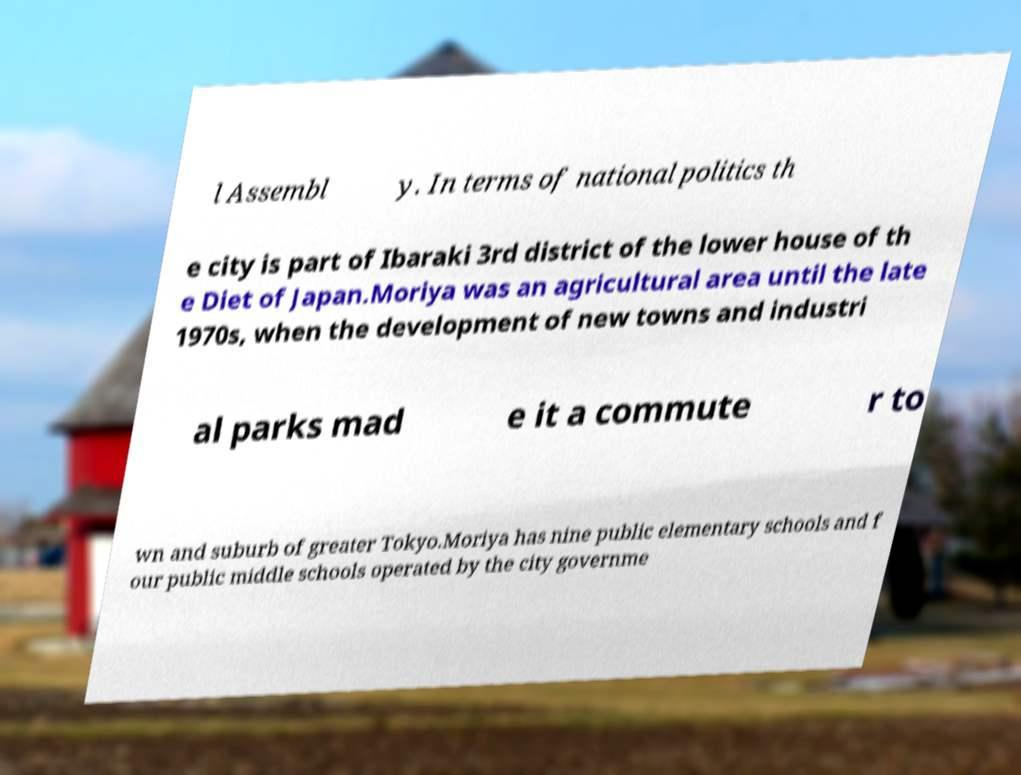I need the written content from this picture converted into text. Can you do that? l Assembl y. In terms of national politics th e city is part of Ibaraki 3rd district of the lower house of th e Diet of Japan.Moriya was an agricultural area until the late 1970s, when the development of new towns and industri al parks mad e it a commute r to wn and suburb of greater Tokyo.Moriya has nine public elementary schools and f our public middle schools operated by the city governme 